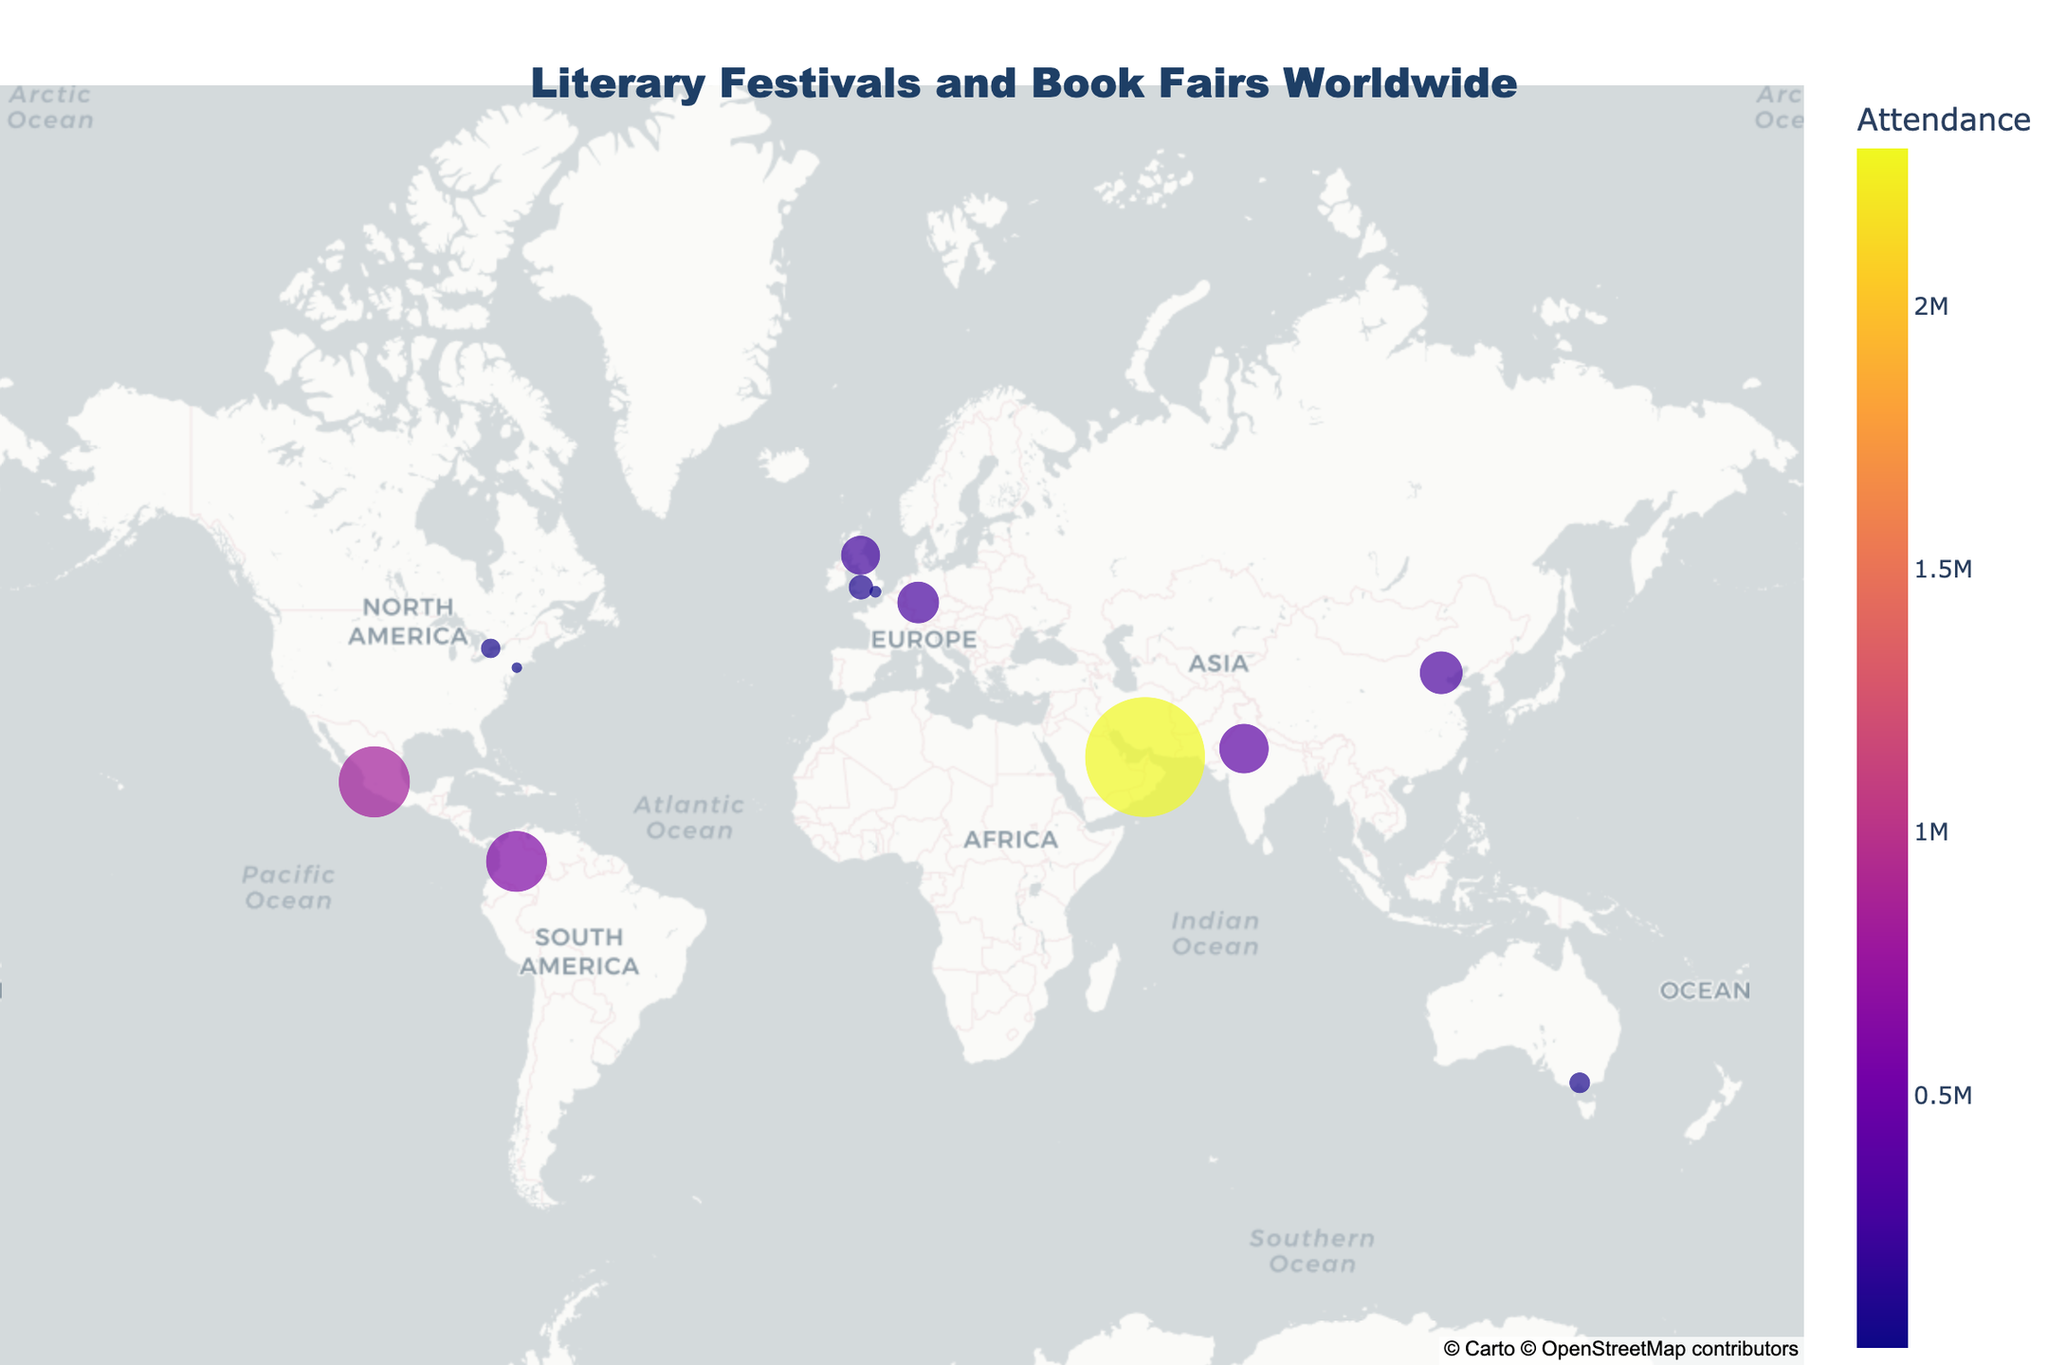How many literary festivals and book fairs are depicted on the map? Count the number of distinct data points scattered across the map, each representing a different festival or book fair.
Answer: 12 Which literary festival has the highest attendance? Look for the largest circle on the map, hover over it to confirm the festival name if necessary.
Answer: Sharjah International Book Fair What's the median attendance of the listed festivals and book fairs? To find the median, first list all attendance figures in order: 20,000; 65,000; 73,000; 100,000; 250,000; 285,000; 300,000; 400,000; 600,000; 818,000; 2,300,000. The middle value (or the average of the two middle values if there's an even number of observations) is the median.
Answer: 285,000 Which festival has the lowest attendance, and what is the figure? Look for the smallest circle on the map, hover over it to ensure the correct festival name and attendance figure.
Answer: BookExpo America, 20,000 How does the attendance at the Frankfurt Book Fair compare to the Jaipur Literature Festival? Locate the circles for both festivals and compare their sizes or hover over them to see the exact attendance figures.
Answer: Frankfurt Book Fair has lower attendance than Jaipur Literature Festival Which continents have the highest representation of literary festivals and book fairs in this map? Observe the geographic distribution of the plotted points and identify the continents with the most data points.
Answer: Europe and Asia Is there any correlation between the location of a city and the attendance of its literary festival? Observe if there is any noticeable pattern regarding the geographical location and size of the points representing attendance figures.
Answer: No clear correlation Compare the attendance of the London Book Fair to the Edinburgh International Book Festival. Locate the circles for both festivals and compare their sizes or hover over them to see the exact attendance figures.
Answer: London Book Fair has lower attendance than Edinburgh International Book Festival What is the average attendance of the literary festivals and book fairs presented on the map? Sum all the attendance figures: 20,000; 65,000; 73,000; 100,000; 250,000; 285,000; 300,000; 400,000; 600,000; 818,000; 2,300,000. Divide the total by the number of festivals (12).
Answer: 471,750 Which region (as specified by latitude and longitude) tends to have the largest festivals in terms of attendance? Hover over regions with large circles to see the corresponding latitude and longitude and check if a pattern emerges.
Answer: South Asia and the Middle East 